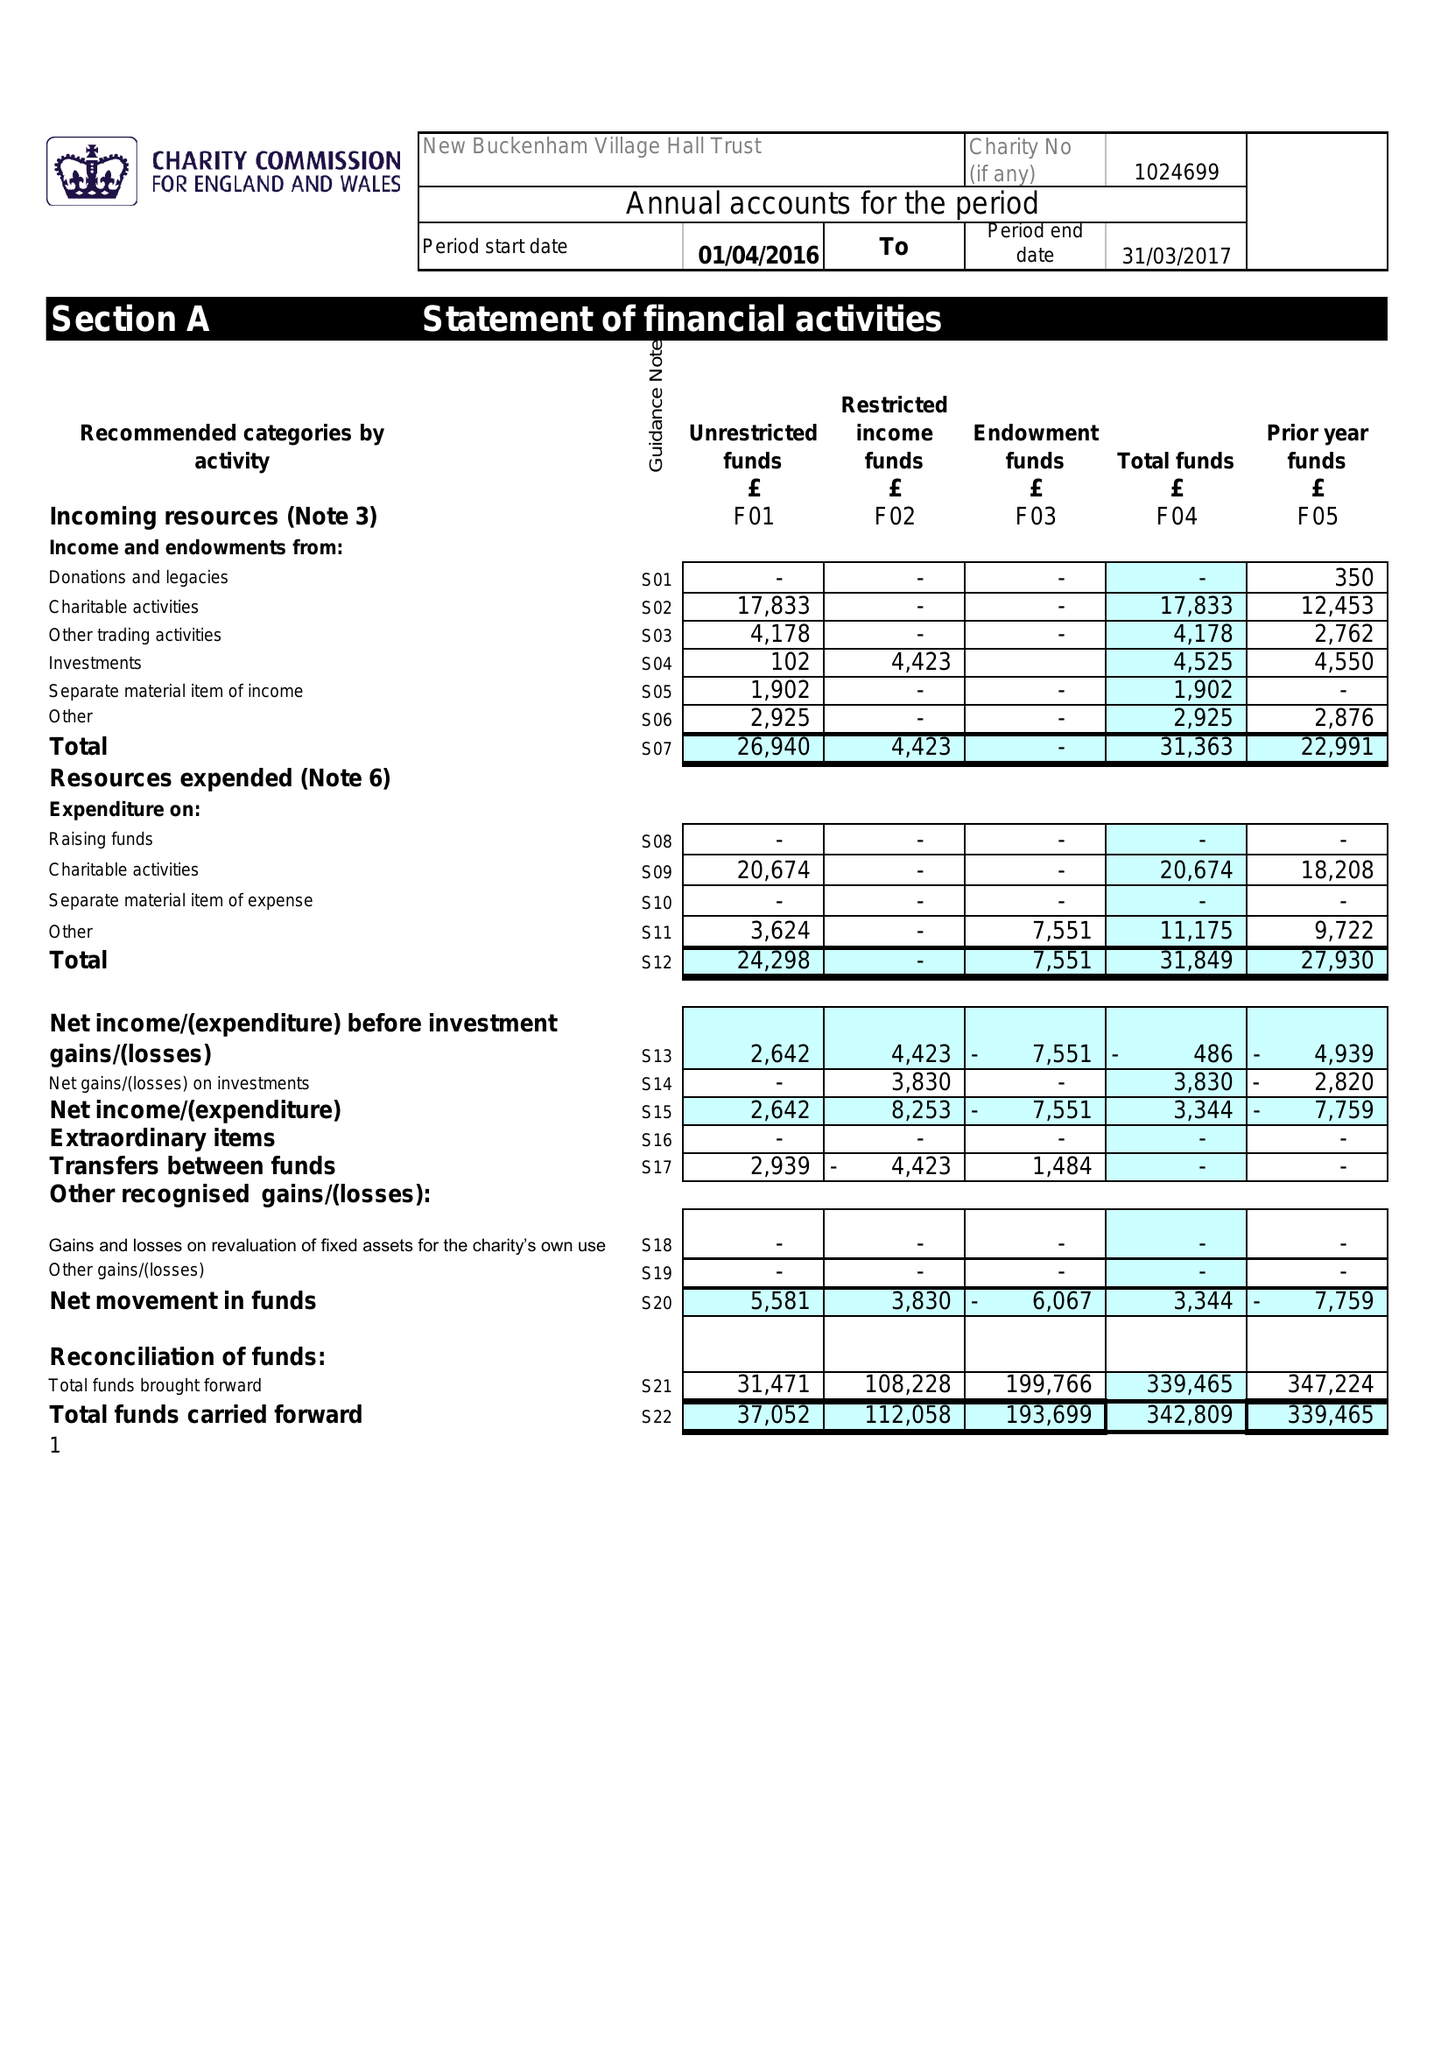What is the value for the income_annually_in_british_pounds?
Answer the question using a single word or phrase. 31363.00 